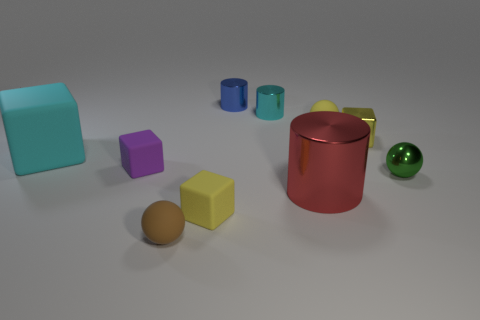Subtract 1 cubes. How many cubes are left? 3 Subtract all cylinders. How many objects are left? 7 Subtract 0 brown blocks. How many objects are left? 10 Subtract all big brown matte cylinders. Subtract all tiny brown things. How many objects are left? 9 Add 2 matte blocks. How many matte blocks are left? 5 Add 4 large cylinders. How many large cylinders exist? 5 